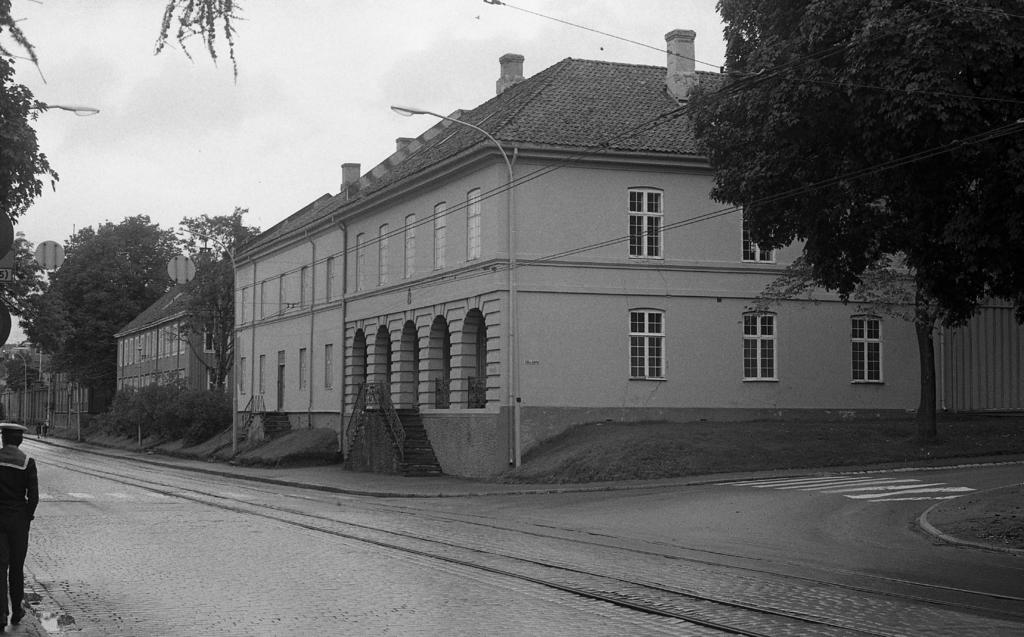What is located in the center of the image? There are buildings in the center of the image. What objects can be seen in the image besides the buildings? There are poles in the image. What type of vegetation is visible in the background of the image? There are trees in the background of the image. What is visible in the background of the image besides the trees? The sky is visible in the background of the image. What type of pies are being served at the carnival in the image? There is no carnival or pies present in the image; it features buildings, poles, trees, and the sky. What type of collar is on the dog in the image? There is no dog or collar present in the image. 